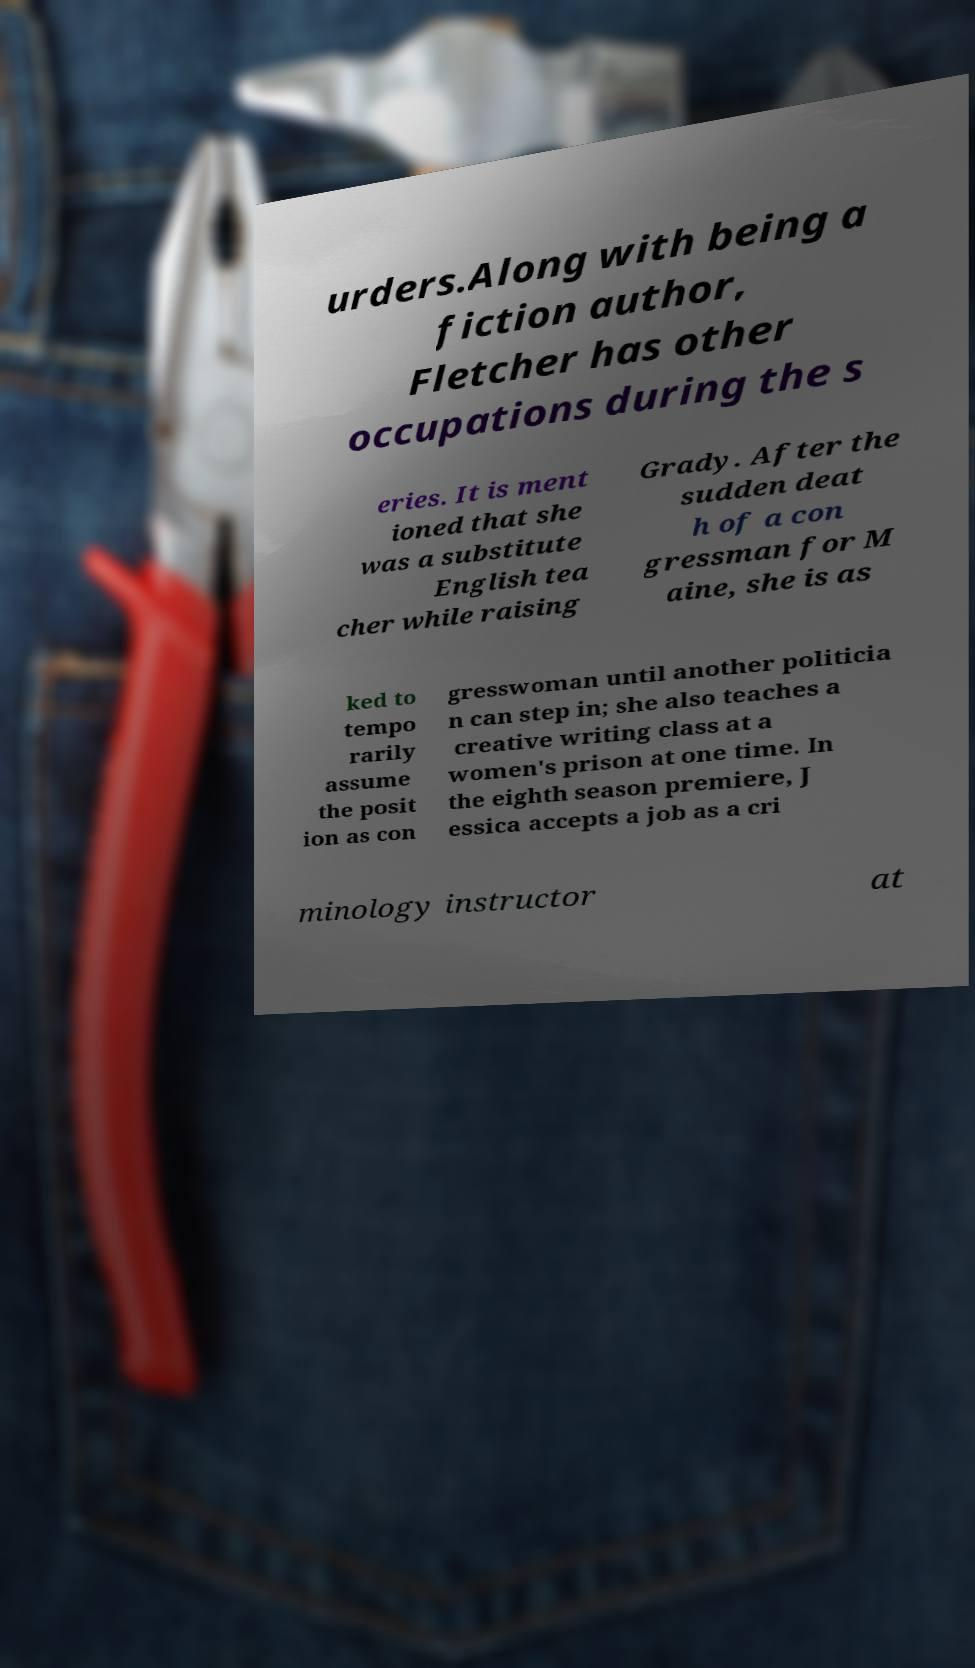There's text embedded in this image that I need extracted. Can you transcribe it verbatim? urders.Along with being a fiction author, Fletcher has other occupations during the s eries. It is ment ioned that she was a substitute English tea cher while raising Grady. After the sudden deat h of a con gressman for M aine, she is as ked to tempo rarily assume the posit ion as con gresswoman until another politicia n can step in; she also teaches a creative writing class at a women's prison at one time. In the eighth season premiere, J essica accepts a job as a cri minology instructor at 